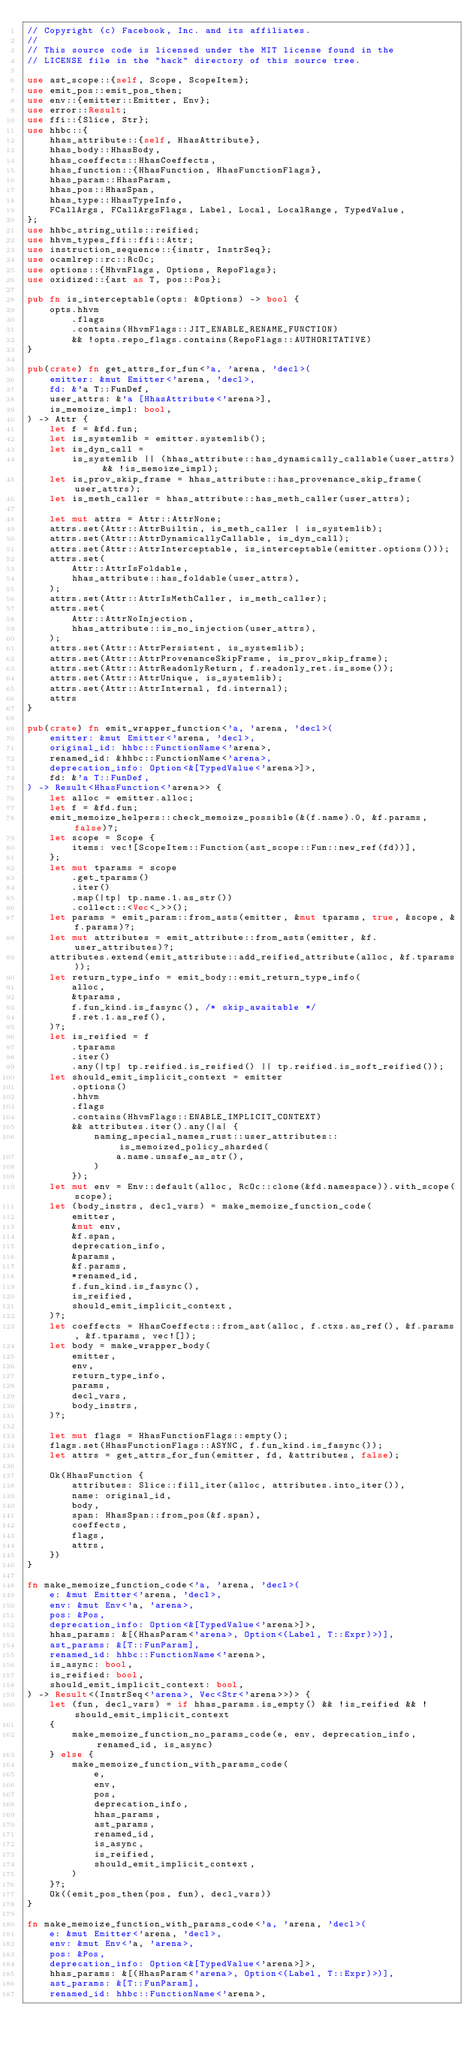Convert code to text. <code><loc_0><loc_0><loc_500><loc_500><_Rust_>// Copyright (c) Facebook, Inc. and its affiliates.
//
// This source code is licensed under the MIT license found in the
// LICENSE file in the "hack" directory of this source tree.

use ast_scope::{self, Scope, ScopeItem};
use emit_pos::emit_pos_then;
use env::{emitter::Emitter, Env};
use error::Result;
use ffi::{Slice, Str};
use hhbc::{
    hhas_attribute::{self, HhasAttribute},
    hhas_body::HhasBody,
    hhas_coeffects::HhasCoeffects,
    hhas_function::{HhasFunction, HhasFunctionFlags},
    hhas_param::HhasParam,
    hhas_pos::HhasSpan,
    hhas_type::HhasTypeInfo,
    FCallArgs, FCallArgsFlags, Label, Local, LocalRange, TypedValue,
};
use hhbc_string_utils::reified;
use hhvm_types_ffi::ffi::Attr;
use instruction_sequence::{instr, InstrSeq};
use ocamlrep::rc::RcOc;
use options::{HhvmFlags, Options, RepoFlags};
use oxidized::{ast as T, pos::Pos};

pub fn is_interceptable(opts: &Options) -> bool {
    opts.hhvm
        .flags
        .contains(HhvmFlags::JIT_ENABLE_RENAME_FUNCTION)
        && !opts.repo_flags.contains(RepoFlags::AUTHORITATIVE)
}

pub(crate) fn get_attrs_for_fun<'a, 'arena, 'decl>(
    emitter: &mut Emitter<'arena, 'decl>,
    fd: &'a T::FunDef,
    user_attrs: &'a [HhasAttribute<'arena>],
    is_memoize_impl: bool,
) -> Attr {
    let f = &fd.fun;
    let is_systemlib = emitter.systemlib();
    let is_dyn_call =
        is_systemlib || (hhas_attribute::has_dynamically_callable(user_attrs) && !is_memoize_impl);
    let is_prov_skip_frame = hhas_attribute::has_provenance_skip_frame(user_attrs);
    let is_meth_caller = hhas_attribute::has_meth_caller(user_attrs);

    let mut attrs = Attr::AttrNone;
    attrs.set(Attr::AttrBuiltin, is_meth_caller | is_systemlib);
    attrs.set(Attr::AttrDynamicallyCallable, is_dyn_call);
    attrs.set(Attr::AttrInterceptable, is_interceptable(emitter.options()));
    attrs.set(
        Attr::AttrIsFoldable,
        hhas_attribute::has_foldable(user_attrs),
    );
    attrs.set(Attr::AttrIsMethCaller, is_meth_caller);
    attrs.set(
        Attr::AttrNoInjection,
        hhas_attribute::is_no_injection(user_attrs),
    );
    attrs.set(Attr::AttrPersistent, is_systemlib);
    attrs.set(Attr::AttrProvenanceSkipFrame, is_prov_skip_frame);
    attrs.set(Attr::AttrReadonlyReturn, f.readonly_ret.is_some());
    attrs.set(Attr::AttrUnique, is_systemlib);
    attrs.set(Attr::AttrInternal, fd.internal);
    attrs
}

pub(crate) fn emit_wrapper_function<'a, 'arena, 'decl>(
    emitter: &mut Emitter<'arena, 'decl>,
    original_id: hhbc::FunctionName<'arena>,
    renamed_id: &hhbc::FunctionName<'arena>,
    deprecation_info: Option<&[TypedValue<'arena>]>,
    fd: &'a T::FunDef,
) -> Result<HhasFunction<'arena>> {
    let alloc = emitter.alloc;
    let f = &fd.fun;
    emit_memoize_helpers::check_memoize_possible(&(f.name).0, &f.params, false)?;
    let scope = Scope {
        items: vec![ScopeItem::Function(ast_scope::Fun::new_ref(fd))],
    };
    let mut tparams = scope
        .get_tparams()
        .iter()
        .map(|tp| tp.name.1.as_str())
        .collect::<Vec<_>>();
    let params = emit_param::from_asts(emitter, &mut tparams, true, &scope, &f.params)?;
    let mut attributes = emit_attribute::from_asts(emitter, &f.user_attributes)?;
    attributes.extend(emit_attribute::add_reified_attribute(alloc, &f.tparams));
    let return_type_info = emit_body::emit_return_type_info(
        alloc,
        &tparams,
        f.fun_kind.is_fasync(), /* skip_awaitable */
        f.ret.1.as_ref(),
    )?;
    let is_reified = f
        .tparams
        .iter()
        .any(|tp| tp.reified.is_reified() || tp.reified.is_soft_reified());
    let should_emit_implicit_context = emitter
        .options()
        .hhvm
        .flags
        .contains(HhvmFlags::ENABLE_IMPLICIT_CONTEXT)
        && attributes.iter().any(|a| {
            naming_special_names_rust::user_attributes::is_memoized_policy_sharded(
                a.name.unsafe_as_str(),
            )
        });
    let mut env = Env::default(alloc, RcOc::clone(&fd.namespace)).with_scope(scope);
    let (body_instrs, decl_vars) = make_memoize_function_code(
        emitter,
        &mut env,
        &f.span,
        deprecation_info,
        &params,
        &f.params,
        *renamed_id,
        f.fun_kind.is_fasync(),
        is_reified,
        should_emit_implicit_context,
    )?;
    let coeffects = HhasCoeffects::from_ast(alloc, f.ctxs.as_ref(), &f.params, &f.tparams, vec![]);
    let body = make_wrapper_body(
        emitter,
        env,
        return_type_info,
        params,
        decl_vars,
        body_instrs,
    )?;

    let mut flags = HhasFunctionFlags::empty();
    flags.set(HhasFunctionFlags::ASYNC, f.fun_kind.is_fasync());
    let attrs = get_attrs_for_fun(emitter, fd, &attributes, false);

    Ok(HhasFunction {
        attributes: Slice::fill_iter(alloc, attributes.into_iter()),
        name: original_id,
        body,
        span: HhasSpan::from_pos(&f.span),
        coeffects,
        flags,
        attrs,
    })
}

fn make_memoize_function_code<'a, 'arena, 'decl>(
    e: &mut Emitter<'arena, 'decl>,
    env: &mut Env<'a, 'arena>,
    pos: &Pos,
    deprecation_info: Option<&[TypedValue<'arena>]>,
    hhas_params: &[(HhasParam<'arena>, Option<(Label, T::Expr)>)],
    ast_params: &[T::FunParam],
    renamed_id: hhbc::FunctionName<'arena>,
    is_async: bool,
    is_reified: bool,
    should_emit_implicit_context: bool,
) -> Result<(InstrSeq<'arena>, Vec<Str<'arena>>)> {
    let (fun, decl_vars) = if hhas_params.is_empty() && !is_reified && !should_emit_implicit_context
    {
        make_memoize_function_no_params_code(e, env, deprecation_info, renamed_id, is_async)
    } else {
        make_memoize_function_with_params_code(
            e,
            env,
            pos,
            deprecation_info,
            hhas_params,
            ast_params,
            renamed_id,
            is_async,
            is_reified,
            should_emit_implicit_context,
        )
    }?;
    Ok((emit_pos_then(pos, fun), decl_vars))
}

fn make_memoize_function_with_params_code<'a, 'arena, 'decl>(
    e: &mut Emitter<'arena, 'decl>,
    env: &mut Env<'a, 'arena>,
    pos: &Pos,
    deprecation_info: Option<&[TypedValue<'arena>]>,
    hhas_params: &[(HhasParam<'arena>, Option<(Label, T::Expr)>)],
    ast_params: &[T::FunParam],
    renamed_id: hhbc::FunctionName<'arena>,</code> 